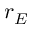Convert formula to latex. <formula><loc_0><loc_0><loc_500><loc_500>r _ { E }</formula> 